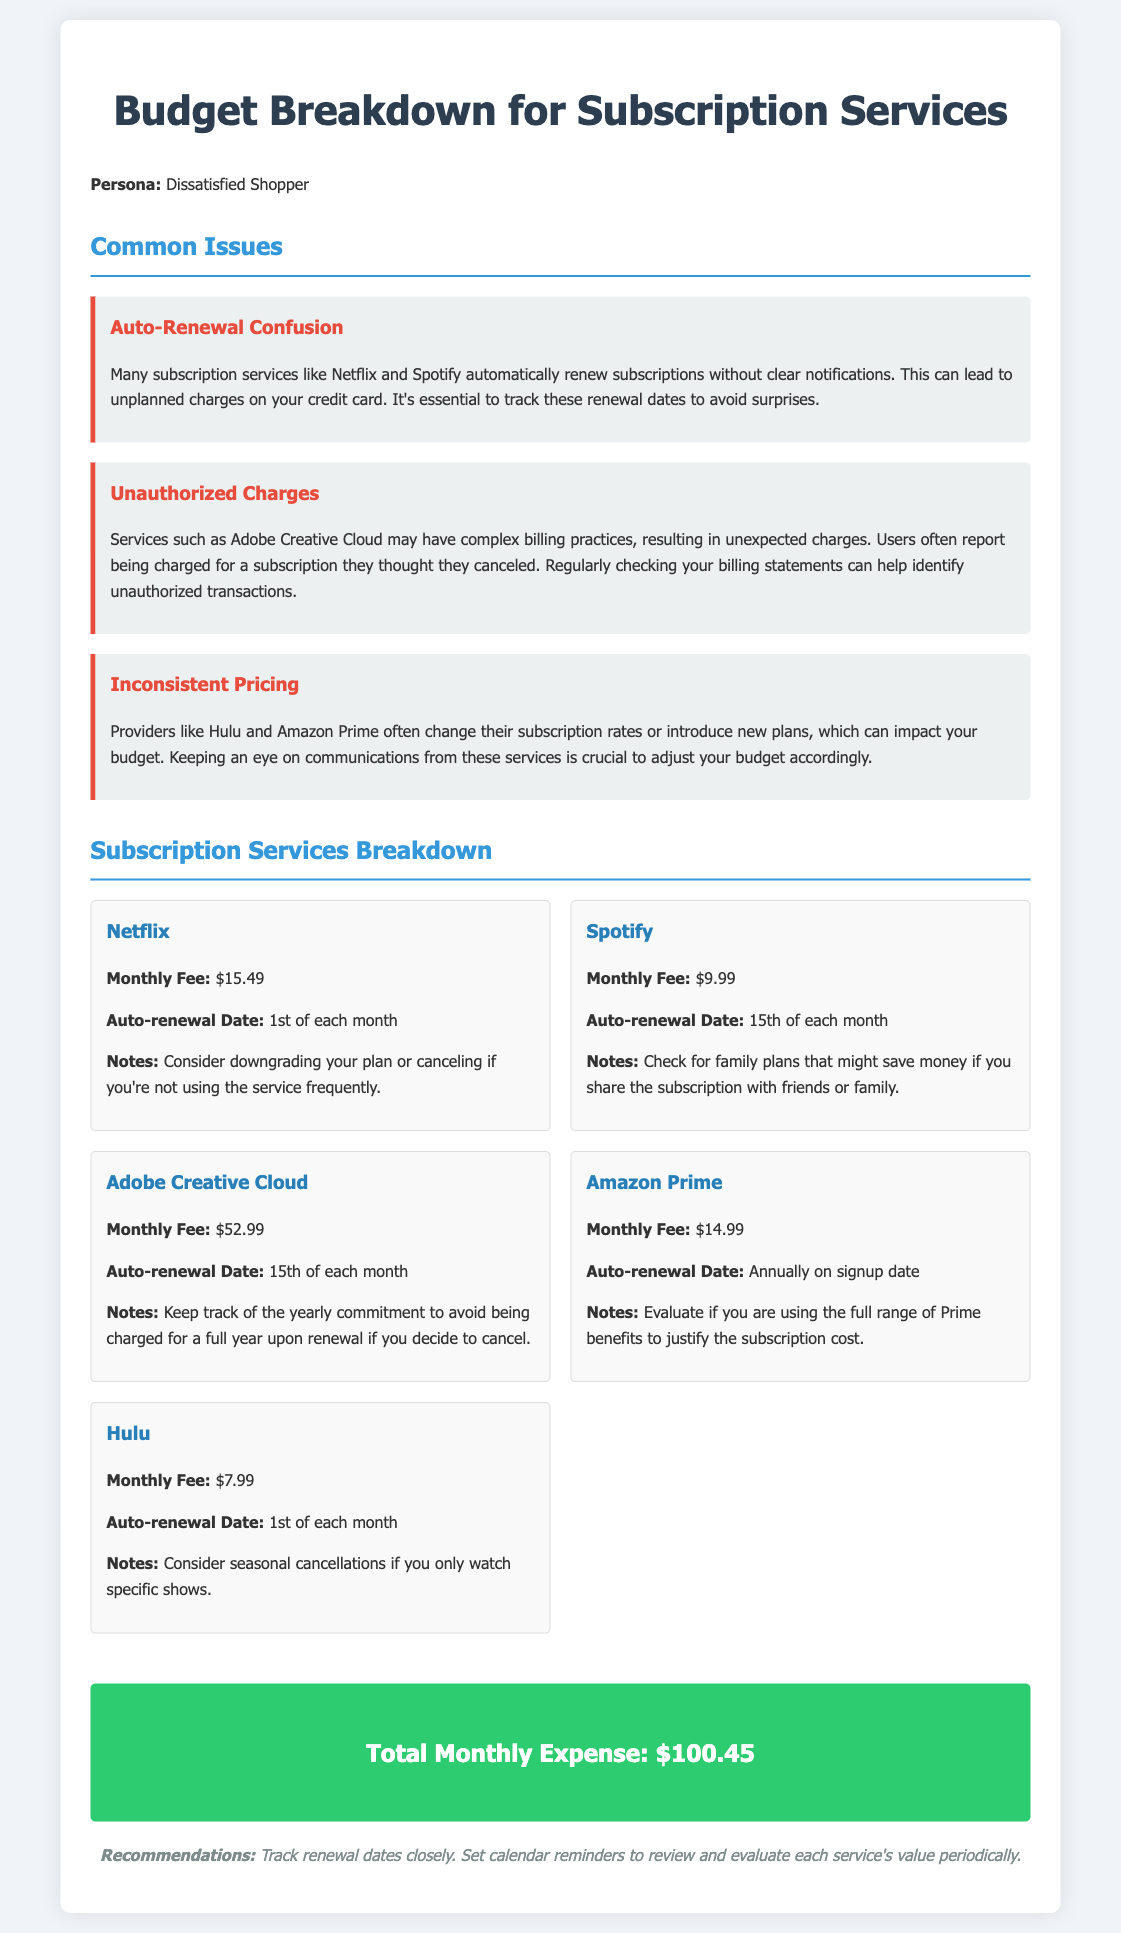What is the monthly fee for Netflix? The document states that the monthly fee for Netflix is $15.49.
Answer: $15.49 When is the auto-renewal date for Adobe Creative Cloud? The document specifies that the auto-renewal date for Adobe Creative Cloud is the 15th of each month.
Answer: 15th of each month What are the total monthly expenses according to the budget breakdown? The total monthly expense is clearly stated in the document as $100.45.
Answer: $100.45 Which service has the highest monthly fee? By comparing the monthly fees listed, Adobe Creative Cloud has the highest monthly fee at $52.99.
Answer: Adobe Creative Cloud What suggestion is given regarding Hulu subscriptions? The document suggests considering seasonal cancellations if only specific shows are watched.
Answer: Seasonal cancellations How often does Amazon Prime auto-renew? It is indicated that Amazon Prime auto-renews annually on the signup date.
Answer: Annually What issue is commonly associated with subscription services like Netflix and Spotify? The document mentions that auto-renewal confusion is a common issue with these services.
Answer: Auto-renewal confusion What should customers track to avoid surprise charges? The document advises customers to track renewal dates to avoid surprises.
Answer: Renewal dates 